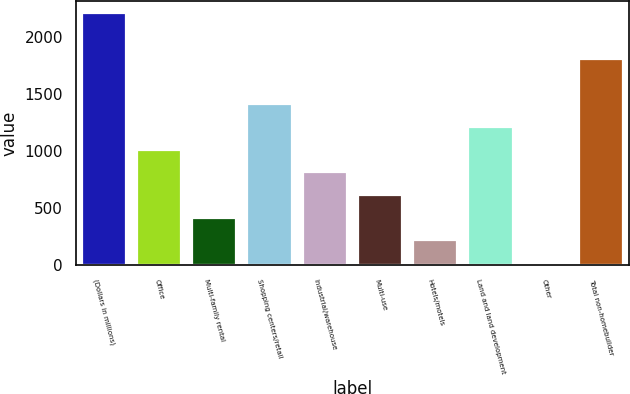<chart> <loc_0><loc_0><loc_500><loc_500><bar_chart><fcel>(Dollars in millions)<fcel>Office<fcel>Multi-family rental<fcel>Shopping centers/retail<fcel>Industrial/warehouse<fcel>Multi-use<fcel>Hotels/motels<fcel>Land and land development<fcel>Other<fcel>Total non-homebuilder<nl><fcel>2210.2<fcel>1015<fcel>417.4<fcel>1413.4<fcel>815.8<fcel>616.6<fcel>218.2<fcel>1214.2<fcel>19<fcel>1811.8<nl></chart> 